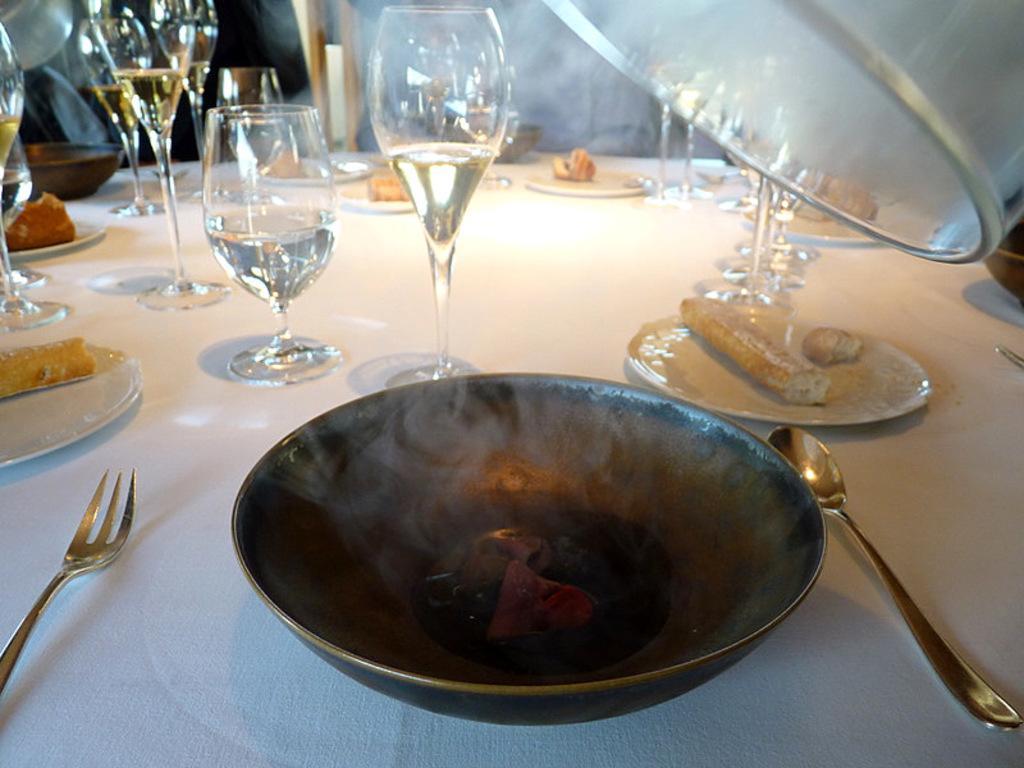Describe this image in one or two sentences. In the center of the image we can see one table. On the table, we can see one cloth, one spoon, one fork, plates, one bowl type object, wine glasses, some food items and a few other objects. At the top right side of the image, we can see one white color object. In the background we can see smoke and a few other objects. 